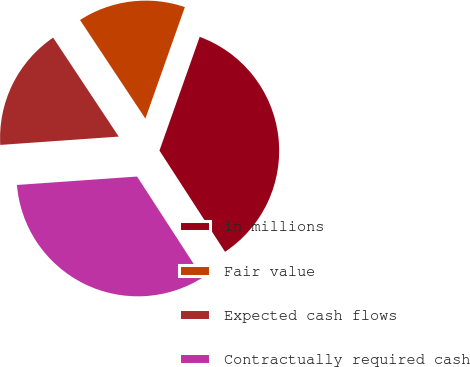Convert chart to OTSL. <chart><loc_0><loc_0><loc_500><loc_500><pie_chart><fcel>in millions<fcel>Fair value<fcel>Expected cash flows<fcel>Contractually required cash<nl><fcel>35.44%<fcel>14.73%<fcel>16.8%<fcel>33.03%<nl></chart> 